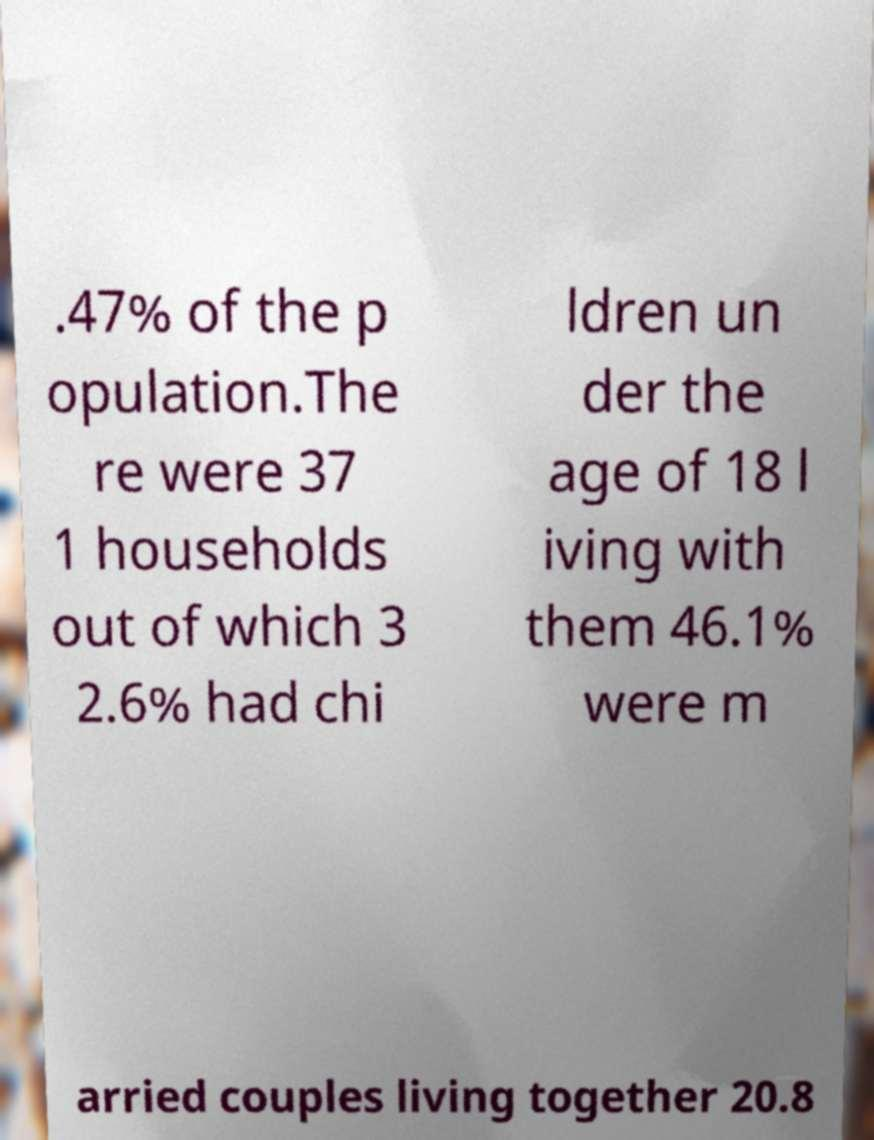What messages or text are displayed in this image? I need them in a readable, typed format. .47% of the p opulation.The re were 37 1 households out of which 3 2.6% had chi ldren un der the age of 18 l iving with them 46.1% were m arried couples living together 20.8 